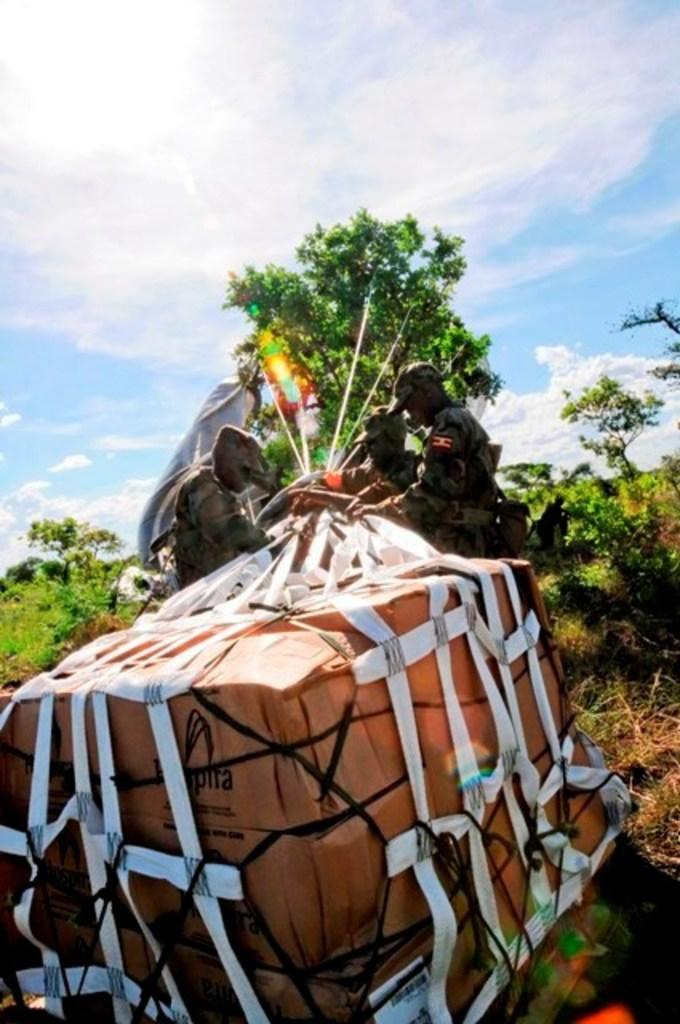Who or what is present in the image? There are people in the image. What objects can be seen alongside the people? There are books in the image. How are the books arranged or contained? The books are in a net. What type of natural elements are visible in the image? There are trees and plants in the image. How many spiders are crawling on the books in the image? There are no spiders present in the image; the books are in a net. 